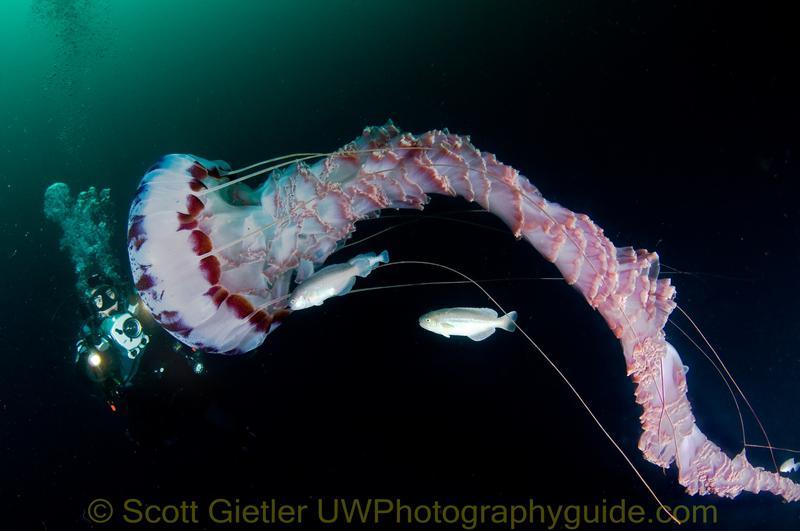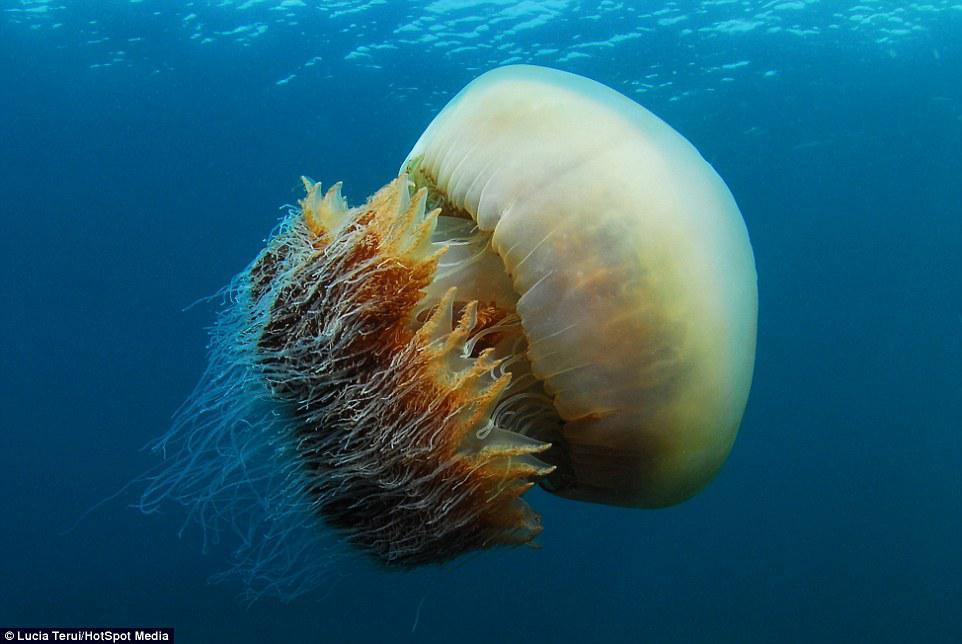The first image is the image on the left, the second image is the image on the right. Assess this claim about the two images: "There is at least one human visible.". Correct or not? Answer yes or no. No. The first image is the image on the left, the second image is the image on the right. For the images shown, is this caption "One jellyfish has pink hues." true? Answer yes or no. Yes. 